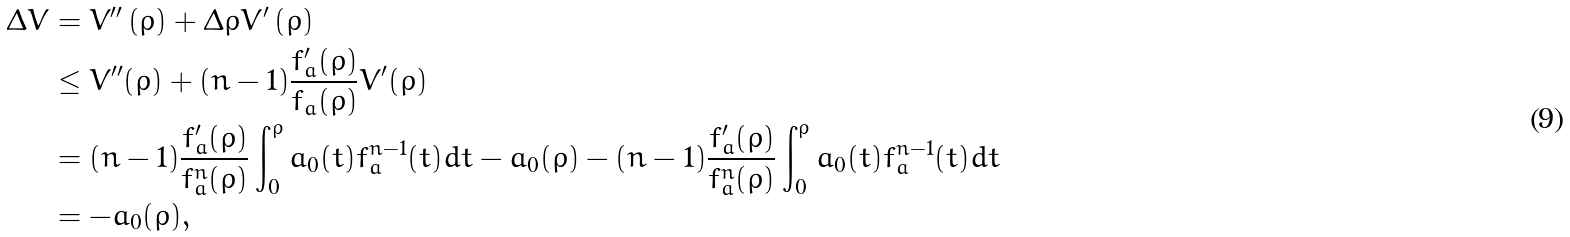<formula> <loc_0><loc_0><loc_500><loc_500>\Delta V & = V ^ { \prime \prime } \left ( \rho \right ) + \Delta \rho V ^ { \prime } \left ( \rho \right ) \\ & \leq V ^ { \prime \prime } ( \rho ) + ( n - 1 ) \frac { f _ { a } ^ { \prime } ( \rho ) } { f _ { a } ( \rho ) } V ^ { \prime } ( \rho ) \\ & = ( n - 1 ) \frac { f _ { a } ^ { \prime } ( \rho ) } { f _ { a } ^ { n } ( \rho ) } \int _ { 0 } ^ { \rho } a _ { 0 } ( t ) f _ { a } ^ { n - 1 } ( t ) d t - a _ { 0 } ( \rho ) - ( n - 1 ) \frac { f _ { a } ^ { \prime } ( \rho ) } { f _ { a } ^ { n } ( \rho ) } \int _ { 0 } ^ { \rho } a _ { 0 } ( t ) f _ { a } ^ { n - 1 } ( t ) d t \\ & = - a _ { 0 } ( \rho ) ,</formula> 